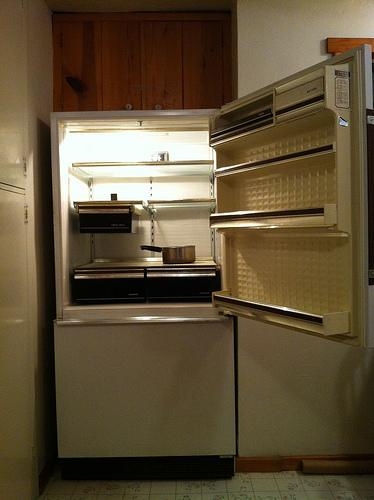How many glass refrigerator shelves can you count in the image? There are four glass refrigerator shelves. Mention the color and type of the surface that the refrigerator is placed on. The refrigerator is placed on a white and floral tiled floor. Which objects are stored in the main appliance in the picture? A metal sauce pan and several black refrigerator drawers are inside the open refrigerator. Identify the type of storage compartments available in the refrigerator door and their state. There are refrigerator door shelves and a compartment with the word "butter" written on it, all present in the open door. Are there any noteworthy features on the refrigerator's exterior, such as handles or hinges? There's a handle on the freezer and hinges on the doors. Describe the floor pattern in this image and any objects found on the floor. The floor has a white vinyl flooring with a floral pattern, and there is a brown cardboard tube lying on it. Identify the type of room this image is taken in and describe the main appliance and its state. This image showcases a kitchen with an open white refrigerator and freezer, with the door wide open and empty shelves. Describe the walls surrounding the refrigerator and any notable features. There's a yellow wall on the shelves, a white wall behind the fridge, and wooden trim to the right of the refrigerator. What kind of cabinets can be seen in the image, and where are they located? There are brown wood cabinets above the refrigerator and a white cabinet to the left of the refrigerator. How would you describe the lighting inside the refrigerator? There's a bright white light shining in the open refrigerator. What activities can be inferred from the open refrigerator and the empty shelves? Someone is cleaning the refrigerator or looking for something to eat. Which of these objects can be found in the refrigerator? A) Metal sauce pan B) Cardboard tube C) Wooden cabinets D) Floral tiles A) Metal sauce pan What type of refrigerator is depicted in the image? A white refrigerator freezer with a bottom mount freezer What is the pattern on the floor of the image? White vinyl flooring with floral pattern Describe the floor in the image. White and floral tiled floor What kind of event can be inferred from the image? The refrigerator is being emptied or there is a need to restock the fridge. What does the text on the door compartment say? Butter Describe the cabinets seen above the refrigerator. Brown wood cabinets Explain the expression of characters depicted in the image. There are no characters in the image. Describe the placement of the steel pot inside the given image. Inside the refrigerator Which objects can be found in the open refrigerator door shelf? None, the shelves are empty Identify which objects have shelves on them. Refrigerator, refrigerator door How many drawers can you find inside the refrigerator? Five drawers What is the location of the wooden trim in relation to the refrigerator? To the right of the refrigerator Create a detailed caption for the image. An open white refrigerator freezer with empty shelves and drawers, a metal sauce pan inside, and wooden cabinets above on floral patterned floor. How many light sources are there in the image? One bright light inside the refrigerator What is the color and position of cabinets to the left of the refrigerator? White, left side of the refrigerator How many hinges can be observed in the image? Two hinges 